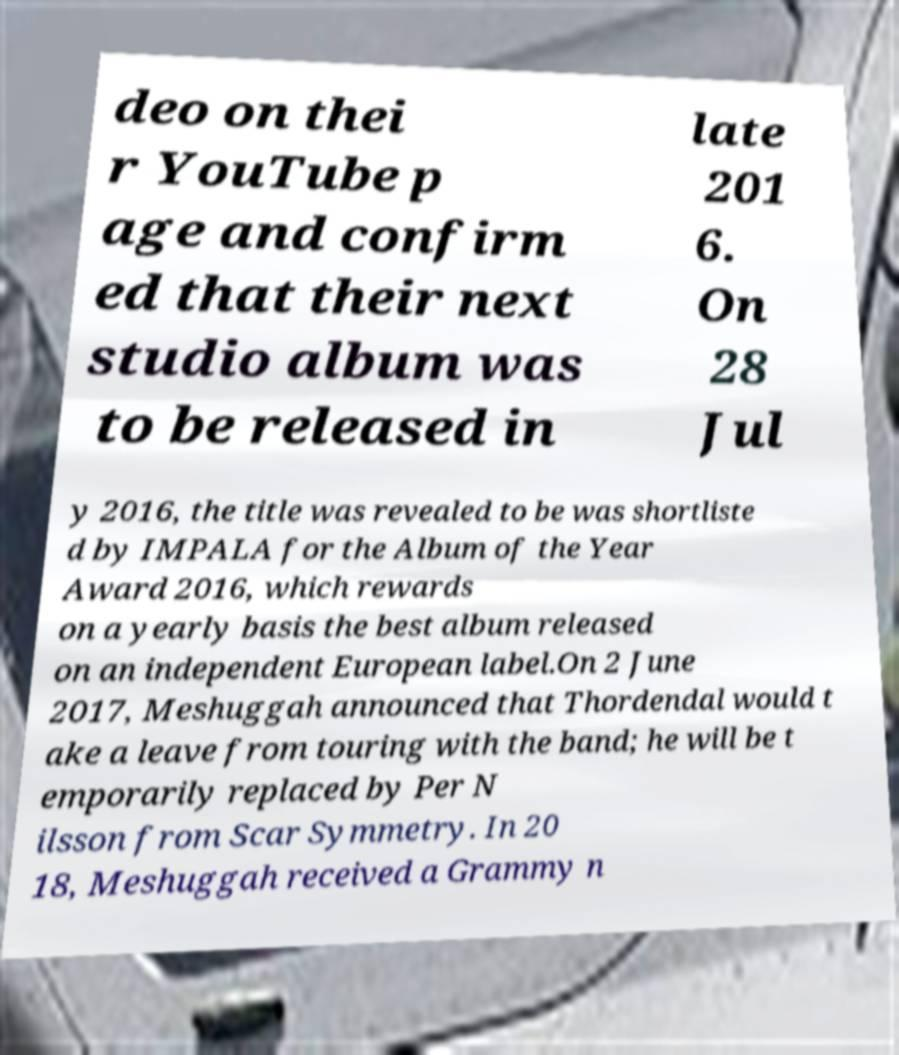Please read and relay the text visible in this image. What does it say? deo on thei r YouTube p age and confirm ed that their next studio album was to be released in late 201 6. On 28 Jul y 2016, the title was revealed to be was shortliste d by IMPALA for the Album of the Year Award 2016, which rewards on a yearly basis the best album released on an independent European label.On 2 June 2017, Meshuggah announced that Thordendal would t ake a leave from touring with the band; he will be t emporarily replaced by Per N ilsson from Scar Symmetry. In 20 18, Meshuggah received a Grammy n 